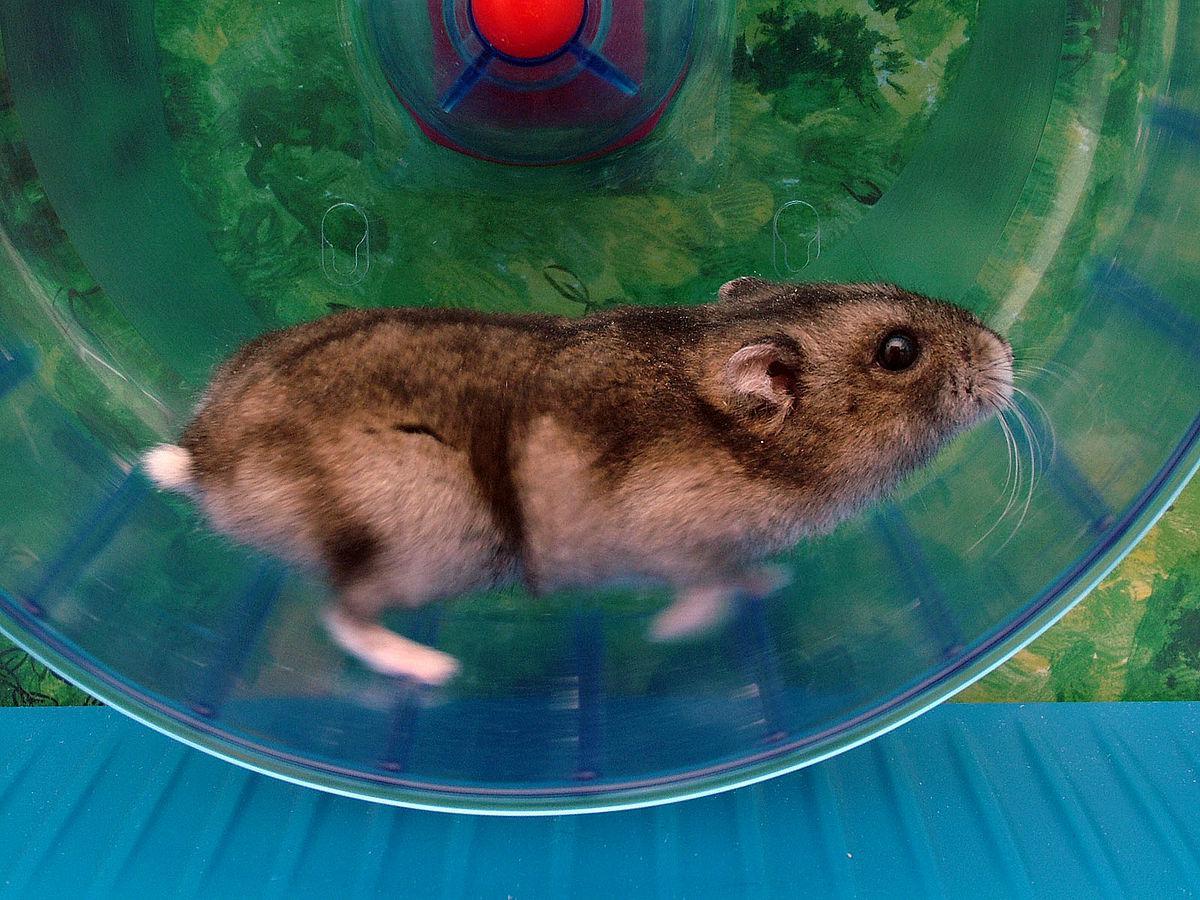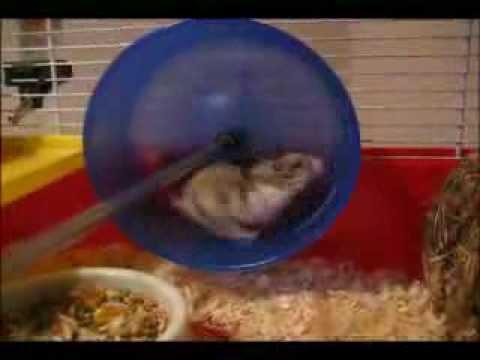The first image is the image on the left, the second image is the image on the right. Assess this claim about the two images: "One image includes a wheel and at least one hamster, but the hamster is not in a running position.". Correct or not? Answer yes or no. No. The first image is the image on the left, the second image is the image on the right. Examine the images to the left and right. Is the description "One of the hamsters is in a metal wheel." accurate? Answer yes or no. No. 